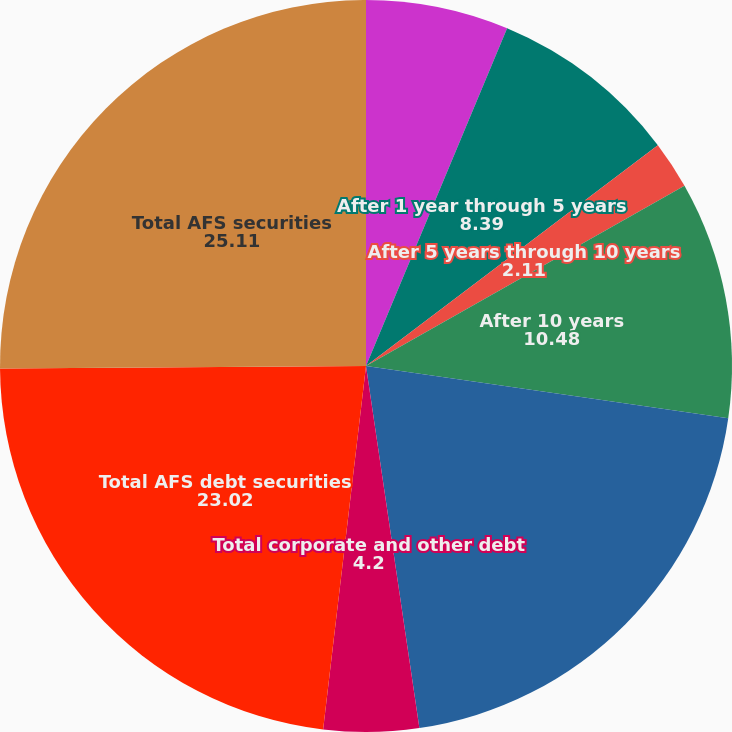Convert chart to OTSL. <chart><loc_0><loc_0><loc_500><loc_500><pie_chart><fcel>Due within 1 year<fcel>After 1 year through 5 years<fcel>After 5 years through 10 years<fcel>After 10 years<fcel>Total US government and agency<fcel>Total corporate and other debt<fcel>Total AFS debt securities<fcel>Total AFS securities<nl><fcel>6.3%<fcel>8.39%<fcel>2.11%<fcel>10.48%<fcel>20.39%<fcel>4.2%<fcel>23.02%<fcel>25.11%<nl></chart> 